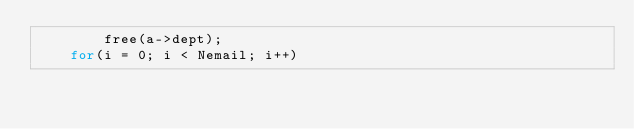<code> <loc_0><loc_0><loc_500><loc_500><_C_>		free(a->dept);
	for(i = 0; i < Nemail; i++)</code> 